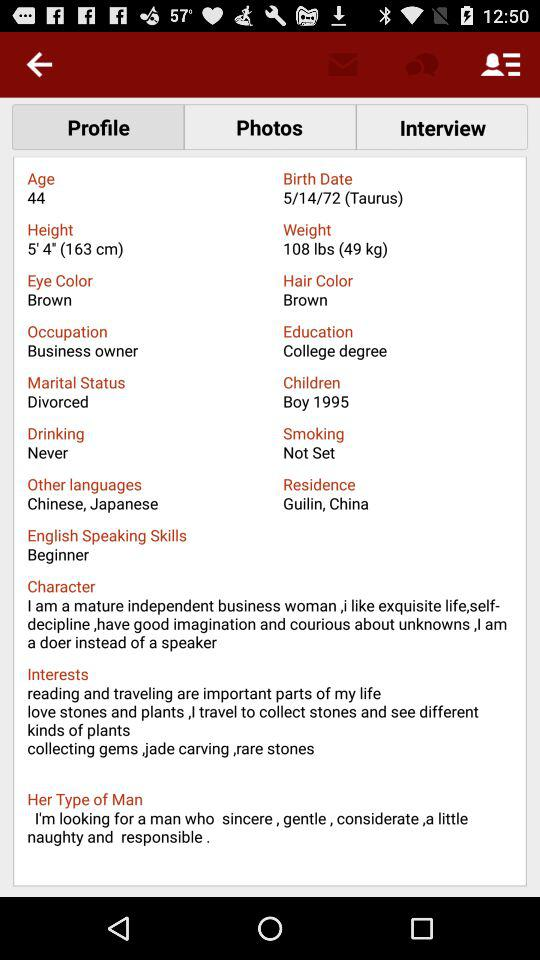What is the eye color? The eye color is brown. 